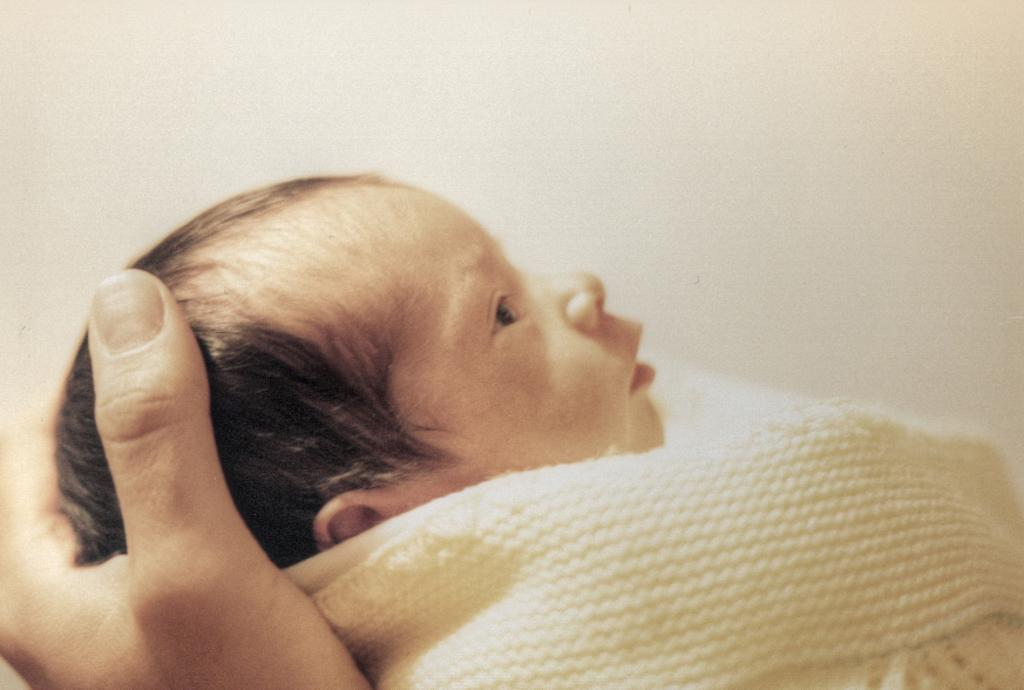What is the main subject of the image? The main subject of the image is a baby. How is the baby being held in the image? The baby is in a person's hand. What type of manager is overseeing the baby's development in the image? There is no manager present in the image, and the baby's development is not mentioned. 